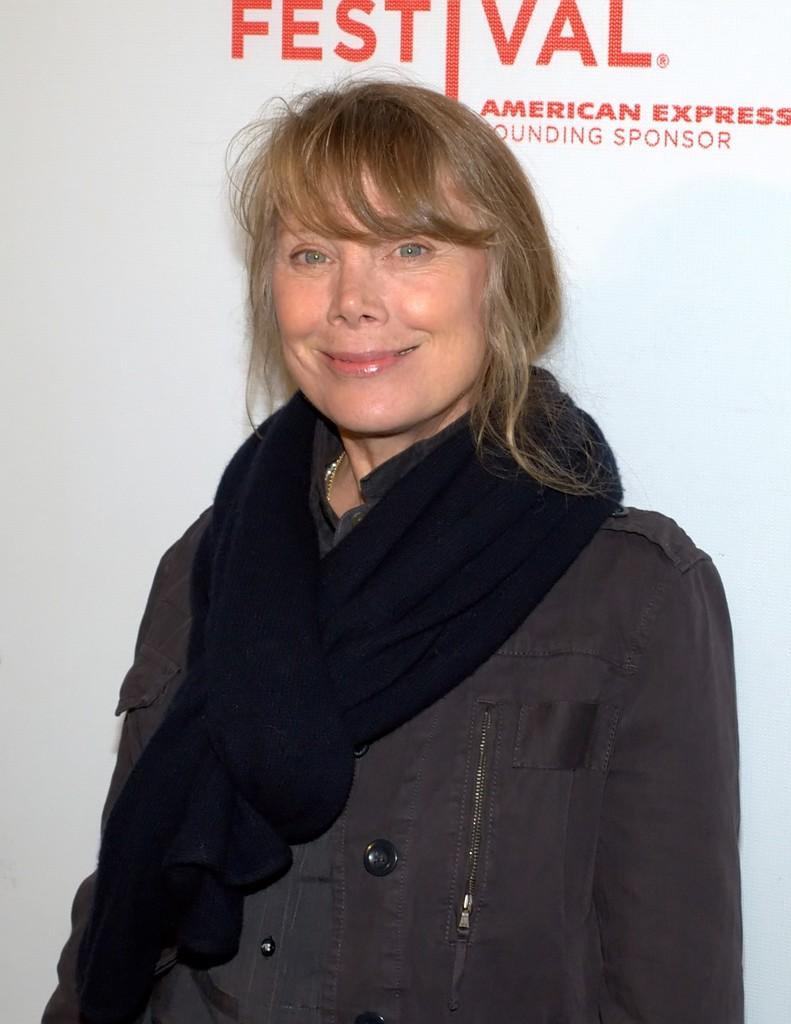What is the main subject of the image? There is a person standing in the image. What can be seen in the background of the image? There appears to be a banner in the background of the image. What is written on the banner? Text is written on the banner. How does the banner expand in the image? The banner does not expand in the image; it is stationary in the background. What type of spark can be seen coming from the person in the image? There is no spark visible in the image; it only features a person standing and a banner in the background. 